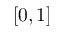Convert formula to latex. <formula><loc_0><loc_0><loc_500><loc_500>[ 0 , 1 ]</formula> 